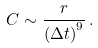<formula> <loc_0><loc_0><loc_500><loc_500>C \sim \frac { r } { { ( \Delta t ) } ^ { 9 } } \, .</formula> 